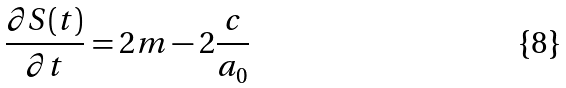Convert formula to latex. <formula><loc_0><loc_0><loc_500><loc_500>\frac { \partial S ( t ) } { \partial t } = 2 m - 2 \frac { c } { a _ { 0 } }</formula> 